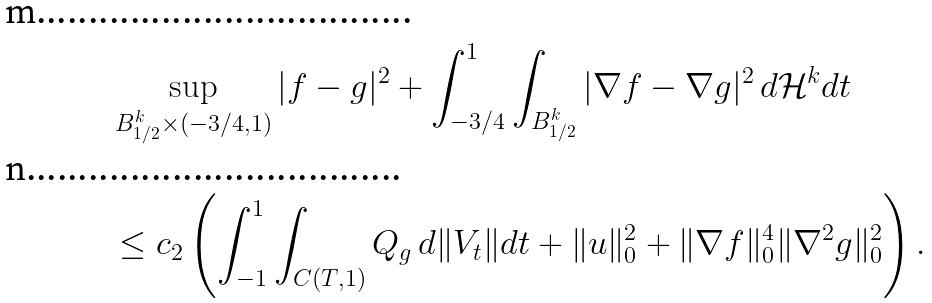<formula> <loc_0><loc_0><loc_500><loc_500>& \sup _ { B _ { 1 / 2 } ^ { k } \times ( - 3 / 4 , 1 ) } | f - g | ^ { 2 } + \int _ { - 3 / 4 } ^ { 1 } \int _ { B _ { 1 / 2 } ^ { k } } | \nabla f - \nabla g | ^ { 2 } \, d { \mathcal { H } } ^ { k } d t \\ & \leq c _ { 2 } \left ( \int _ { - 1 } ^ { 1 } \int _ { C ( T , 1 ) } Q _ { g } \, d \| V _ { t } \| d t + \| u \| _ { 0 } ^ { 2 } + \| \nabla f \| _ { 0 } ^ { 4 } \| \nabla ^ { 2 } g \| ^ { 2 } _ { 0 } \right ) .</formula> 